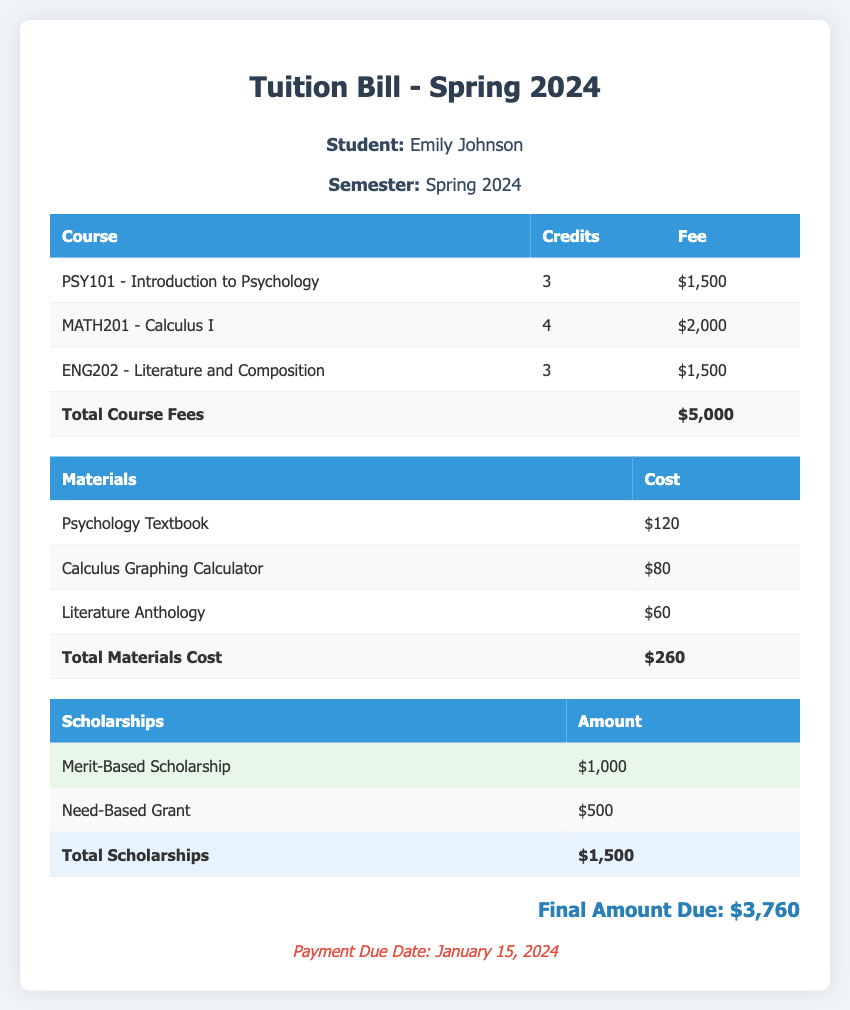What is the student's name? The student's name is displayed at the top of the document under student info.
Answer: Emily Johnson What is the total course fees? The total course fees are calculated at the end of the courses table.
Answer: $5,000 How much is the Literature Anthology? The price is listed under the materials table next to the item.
Answer: $60 What is the total amount for scholarships? The total scholarships are shown at the end of the scholarships table.
Answer: $1,500 What is the final amount due? The final amount due is displayed prominently towards the end of the document.
Answer: $3,760 How many credits does PSY101 have? The number of credits for each course is listed in the courses table.
Answer: 3 When is the payment due date? The payment due date is mentioned at the bottom of the document.
Answer: January 15, 2024 What type of scholarship is the Need-Based Grant? The information about scholarships specifies the type directly next to the name of the scholarship.
Answer: Need-Based What is the cost of the Calculus Graphing Calculator? The cost is indicated next to the item in the materials table.
Answer: $80 